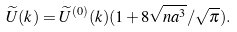<formula> <loc_0><loc_0><loc_500><loc_500>\widetilde { U } ( k ) = \widetilde { U } ^ { ( 0 ) } ( k ) ( 1 + 8 \sqrt { n a ^ { 3 } } / \sqrt { \pi } ) .</formula> 